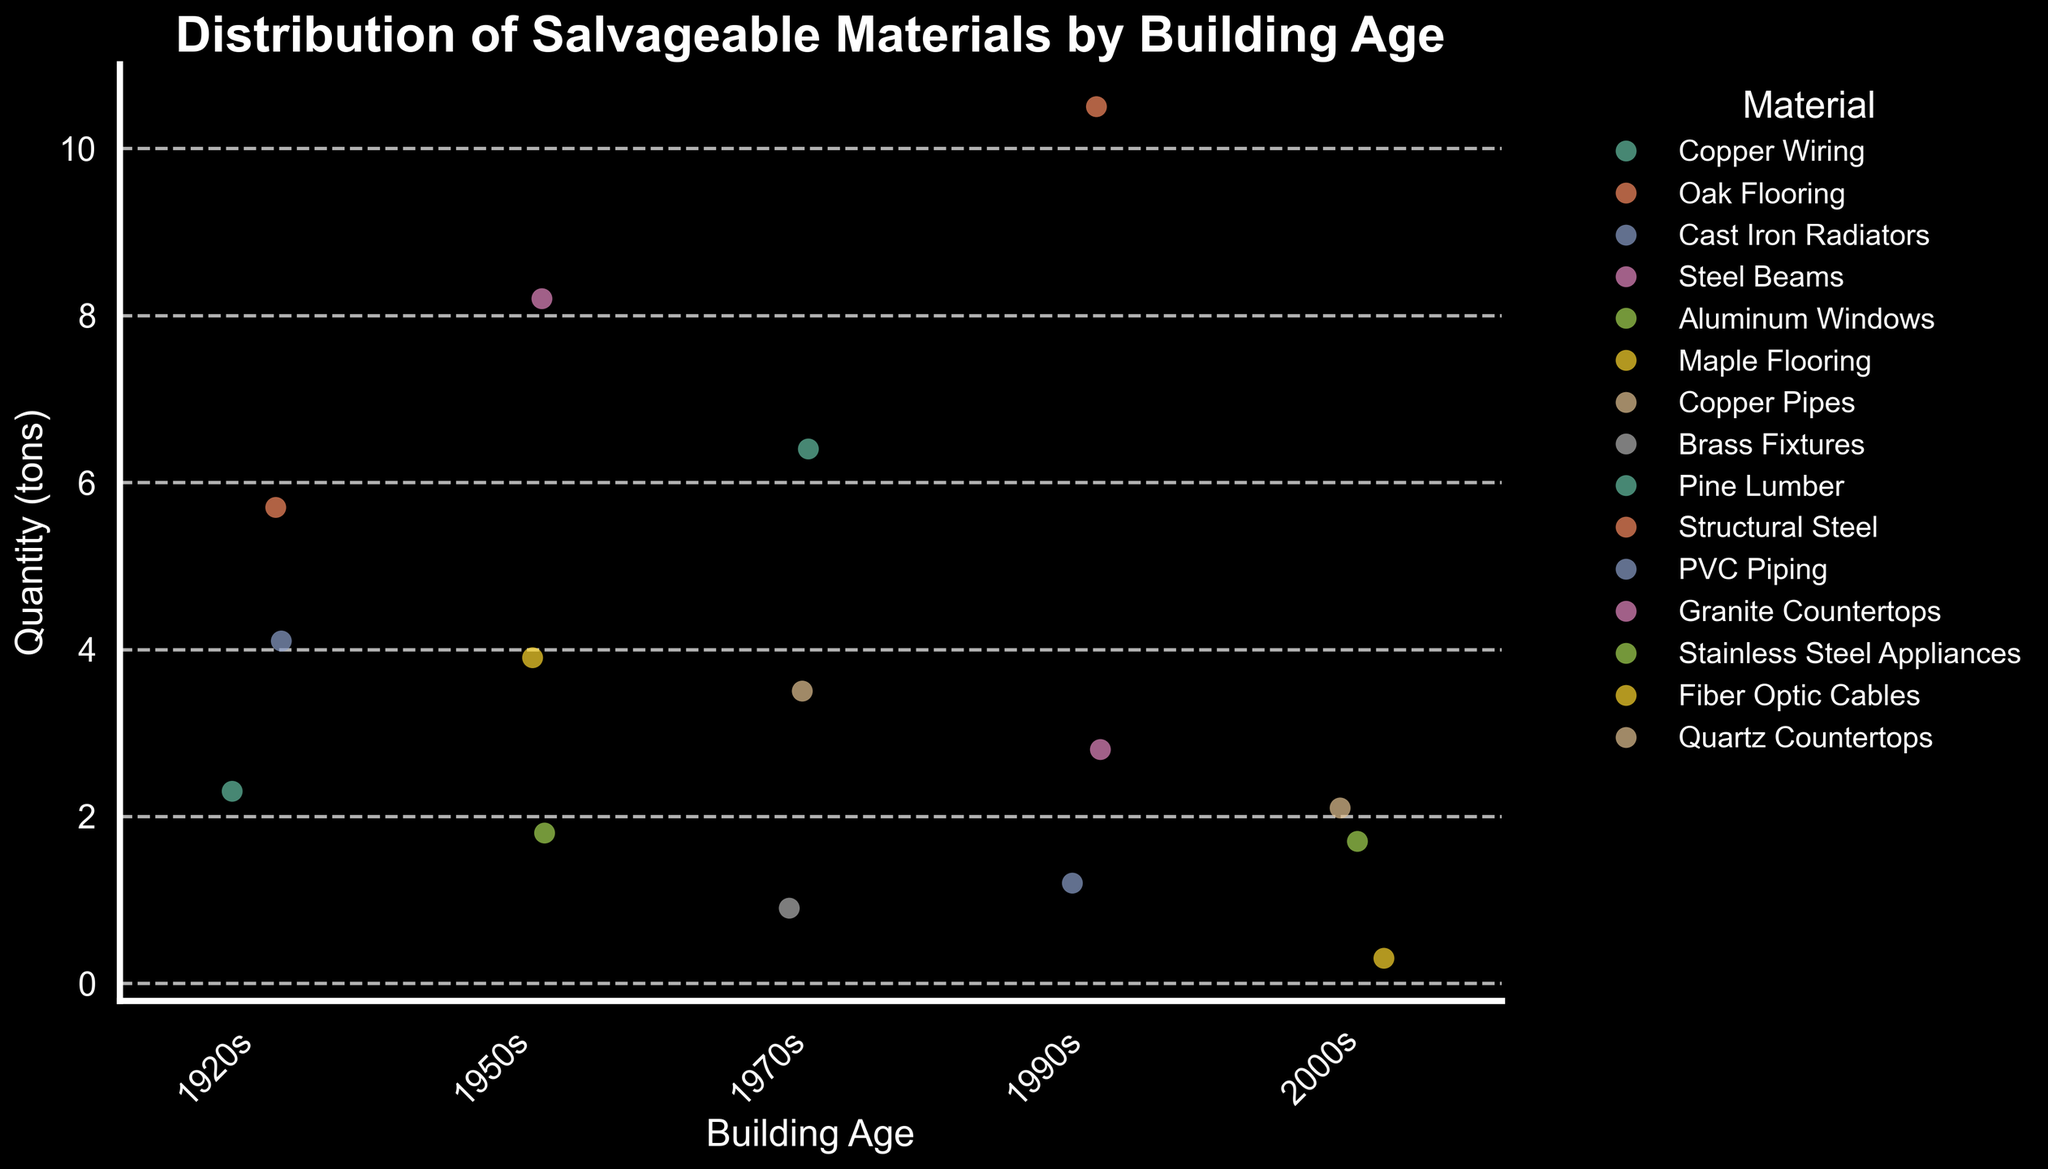What is the title of the plot? The title of the plot is displayed at the top of the figure.
Answer: Distribution of Salvageable Materials by Building Age What is the material with the highest quantity from the 1990s? Look at the 1990s category on the x-axis and identify the material with the highest value on the y-axis.
Answer: Structural Steel How many different materials are shown for buildings from the 1950s? Count the number of unique materials listed in the legend for the 1950s.
Answer: 3 Which building age group has the most diverse types of materials based on the plot? Count the number of unique materials in each building age group by referring to different colors/jitter points in each category.
Answer: 1990s What is the quantity of Cast Iron Radiators from the 1920s? Look at the 1920s category on the x-axis and find the point labeled "Cast Iron Radiators". Read off the corresponding y-value.
Answer: 4.1 Compare the median quantity of materials between the 1950s and the 1970s. Which is higher? Identify the data points for both age groups. Calculate the median by sorting the data points and selecting the middle value.
Answer: 1950s What is the range of quantity values for materials from the 2000s? Find the minimum and maximum y-values for the 2000s category and subtract the minimum value from the maximum value.
Answer: 1.4 Are there any materials with a quantity less than 1 ton from any building age group? Look for data points below the 1-ton mark on the y-axis.
Answer: Yes Identify the building age group with the highest single quantity value for any material. Check all building age groups and identify the highest data point on the y-axis.
Answer: 1990s How does the quantity of copper wiring from the 1920s compare to copper pipes from the 1970s? Locate both points on the plot and compare their quantity values on the y-axis.
Answer: Copper Pipes is higher 